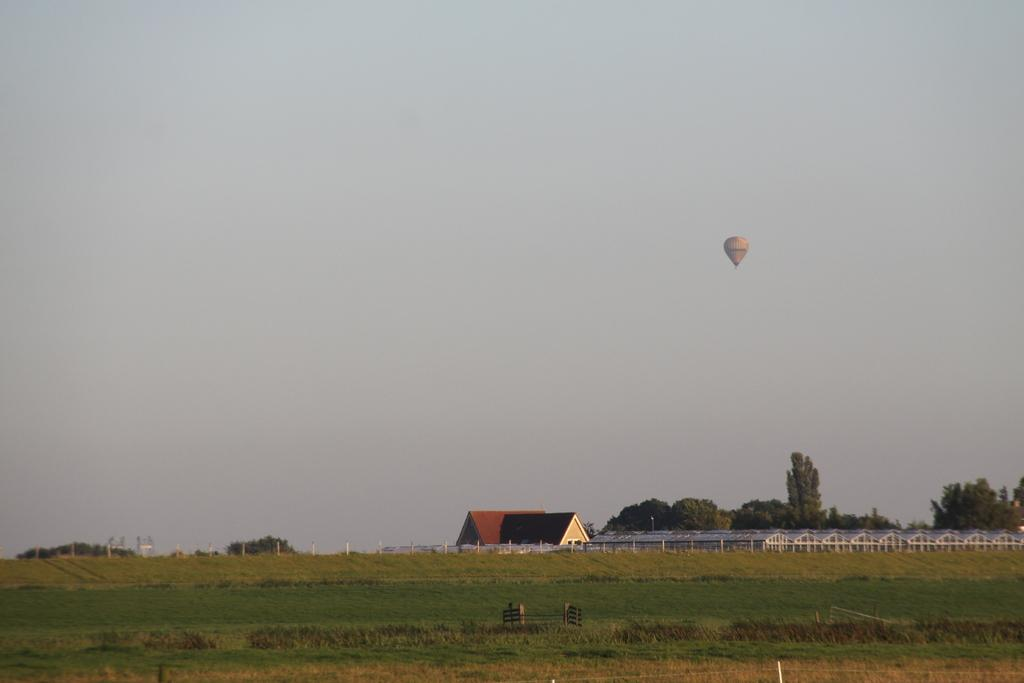What type of structures can be seen in the image? There are houses in the image. What type of vegetation is present in the image? There is grass and trees in the image. What can be seen flying in the sky in the background of the image? There is a parachute flying in the sky in the background of the image. Where is the girl sitting and eating her lunch in the image? There is no girl or lunch present in the image. The image features houses, grass, trees, and a parachute flying in the sky. 